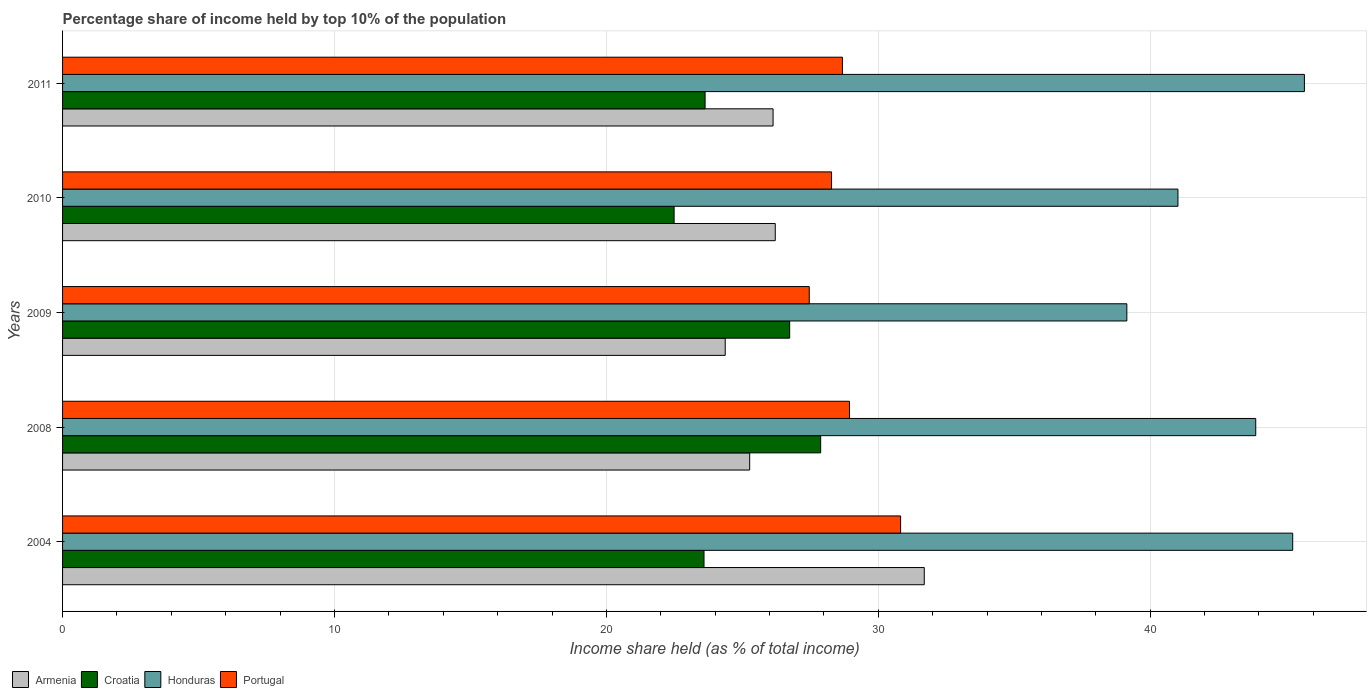Are the number of bars per tick equal to the number of legend labels?
Offer a terse response. Yes. How many bars are there on the 3rd tick from the bottom?
Offer a terse response. 4. What is the label of the 4th group of bars from the top?
Offer a terse response. 2008. What is the percentage share of income held by top 10% of the population in Honduras in 2008?
Keep it short and to the point. 43.88. Across all years, what is the maximum percentage share of income held by top 10% of the population in Armenia?
Your response must be concise. 31.69. Across all years, what is the minimum percentage share of income held by top 10% of the population in Croatia?
Provide a short and direct response. 22.49. In which year was the percentage share of income held by top 10% of the population in Honduras minimum?
Offer a terse response. 2009. What is the total percentage share of income held by top 10% of the population in Honduras in the graph?
Your response must be concise. 214.95. What is the difference between the percentage share of income held by top 10% of the population in Armenia in 2008 and that in 2010?
Your answer should be very brief. -0.94. What is the difference between the percentage share of income held by top 10% of the population in Honduras in 2011 and the percentage share of income held by top 10% of the population in Armenia in 2008?
Offer a terse response. 20.4. What is the average percentage share of income held by top 10% of the population in Portugal per year?
Provide a short and direct response. 28.84. In the year 2009, what is the difference between the percentage share of income held by top 10% of the population in Honduras and percentage share of income held by top 10% of the population in Croatia?
Your answer should be very brief. 12.4. In how many years, is the percentage share of income held by top 10% of the population in Honduras greater than 18 %?
Provide a succinct answer. 5. What is the ratio of the percentage share of income held by top 10% of the population in Armenia in 2008 to that in 2011?
Your response must be concise. 0.97. Is the difference between the percentage share of income held by top 10% of the population in Honduras in 2004 and 2008 greater than the difference between the percentage share of income held by top 10% of the population in Croatia in 2004 and 2008?
Your answer should be very brief. Yes. What is the difference between the highest and the second highest percentage share of income held by top 10% of the population in Portugal?
Your answer should be compact. 1.88. What is the difference between the highest and the lowest percentage share of income held by top 10% of the population in Honduras?
Offer a terse response. 6.53. Is it the case that in every year, the sum of the percentage share of income held by top 10% of the population in Croatia and percentage share of income held by top 10% of the population in Honduras is greater than the sum of percentage share of income held by top 10% of the population in Portugal and percentage share of income held by top 10% of the population in Armenia?
Ensure brevity in your answer.  Yes. What does the 4th bar from the top in 2009 represents?
Your answer should be compact. Armenia. What does the 1st bar from the bottom in 2011 represents?
Your answer should be very brief. Armenia. Is it the case that in every year, the sum of the percentage share of income held by top 10% of the population in Portugal and percentage share of income held by top 10% of the population in Honduras is greater than the percentage share of income held by top 10% of the population in Croatia?
Make the answer very short. Yes. How many bars are there?
Provide a short and direct response. 20. Are all the bars in the graph horizontal?
Provide a succinct answer. Yes. How many years are there in the graph?
Your response must be concise. 5. Does the graph contain grids?
Your response must be concise. Yes. How are the legend labels stacked?
Provide a succinct answer. Horizontal. What is the title of the graph?
Give a very brief answer. Percentage share of income held by top 10% of the population. What is the label or title of the X-axis?
Ensure brevity in your answer.  Income share held (as % of total income). What is the Income share held (as % of total income) in Armenia in 2004?
Your answer should be very brief. 31.69. What is the Income share held (as % of total income) in Croatia in 2004?
Give a very brief answer. 23.59. What is the Income share held (as % of total income) of Honduras in 2004?
Your answer should be compact. 45.24. What is the Income share held (as % of total income) of Portugal in 2004?
Offer a terse response. 30.82. What is the Income share held (as % of total income) of Armenia in 2008?
Provide a short and direct response. 25.27. What is the Income share held (as % of total income) of Croatia in 2008?
Offer a terse response. 27.88. What is the Income share held (as % of total income) in Honduras in 2008?
Ensure brevity in your answer.  43.88. What is the Income share held (as % of total income) of Portugal in 2008?
Keep it short and to the point. 28.94. What is the Income share held (as % of total income) in Armenia in 2009?
Provide a succinct answer. 24.37. What is the Income share held (as % of total income) in Croatia in 2009?
Provide a short and direct response. 26.74. What is the Income share held (as % of total income) in Honduras in 2009?
Offer a very short reply. 39.14. What is the Income share held (as % of total income) of Portugal in 2009?
Offer a very short reply. 27.46. What is the Income share held (as % of total income) in Armenia in 2010?
Your response must be concise. 26.21. What is the Income share held (as % of total income) in Croatia in 2010?
Offer a terse response. 22.49. What is the Income share held (as % of total income) in Honduras in 2010?
Give a very brief answer. 41.02. What is the Income share held (as % of total income) of Portugal in 2010?
Offer a very short reply. 28.28. What is the Income share held (as % of total income) in Armenia in 2011?
Keep it short and to the point. 26.13. What is the Income share held (as % of total income) of Croatia in 2011?
Provide a short and direct response. 23.63. What is the Income share held (as % of total income) in Honduras in 2011?
Offer a very short reply. 45.67. What is the Income share held (as % of total income) of Portugal in 2011?
Offer a terse response. 28.68. Across all years, what is the maximum Income share held (as % of total income) in Armenia?
Your answer should be very brief. 31.69. Across all years, what is the maximum Income share held (as % of total income) of Croatia?
Ensure brevity in your answer.  27.88. Across all years, what is the maximum Income share held (as % of total income) in Honduras?
Offer a very short reply. 45.67. Across all years, what is the maximum Income share held (as % of total income) of Portugal?
Provide a short and direct response. 30.82. Across all years, what is the minimum Income share held (as % of total income) of Armenia?
Your answer should be compact. 24.37. Across all years, what is the minimum Income share held (as % of total income) in Croatia?
Provide a succinct answer. 22.49. Across all years, what is the minimum Income share held (as % of total income) of Honduras?
Your response must be concise. 39.14. Across all years, what is the minimum Income share held (as % of total income) in Portugal?
Your answer should be compact. 27.46. What is the total Income share held (as % of total income) in Armenia in the graph?
Your answer should be compact. 133.67. What is the total Income share held (as % of total income) in Croatia in the graph?
Keep it short and to the point. 124.33. What is the total Income share held (as % of total income) in Honduras in the graph?
Your answer should be very brief. 214.95. What is the total Income share held (as % of total income) of Portugal in the graph?
Offer a very short reply. 144.18. What is the difference between the Income share held (as % of total income) of Armenia in 2004 and that in 2008?
Give a very brief answer. 6.42. What is the difference between the Income share held (as % of total income) of Croatia in 2004 and that in 2008?
Ensure brevity in your answer.  -4.29. What is the difference between the Income share held (as % of total income) of Honduras in 2004 and that in 2008?
Your answer should be very brief. 1.36. What is the difference between the Income share held (as % of total income) of Portugal in 2004 and that in 2008?
Provide a succinct answer. 1.88. What is the difference between the Income share held (as % of total income) in Armenia in 2004 and that in 2009?
Your response must be concise. 7.32. What is the difference between the Income share held (as % of total income) of Croatia in 2004 and that in 2009?
Your answer should be compact. -3.15. What is the difference between the Income share held (as % of total income) of Honduras in 2004 and that in 2009?
Provide a short and direct response. 6.1. What is the difference between the Income share held (as % of total income) of Portugal in 2004 and that in 2009?
Provide a short and direct response. 3.36. What is the difference between the Income share held (as % of total income) of Armenia in 2004 and that in 2010?
Keep it short and to the point. 5.48. What is the difference between the Income share held (as % of total income) of Croatia in 2004 and that in 2010?
Make the answer very short. 1.1. What is the difference between the Income share held (as % of total income) in Honduras in 2004 and that in 2010?
Your response must be concise. 4.22. What is the difference between the Income share held (as % of total income) in Portugal in 2004 and that in 2010?
Keep it short and to the point. 2.54. What is the difference between the Income share held (as % of total income) in Armenia in 2004 and that in 2011?
Keep it short and to the point. 5.56. What is the difference between the Income share held (as % of total income) in Croatia in 2004 and that in 2011?
Provide a succinct answer. -0.04. What is the difference between the Income share held (as % of total income) in Honduras in 2004 and that in 2011?
Make the answer very short. -0.43. What is the difference between the Income share held (as % of total income) in Portugal in 2004 and that in 2011?
Offer a terse response. 2.14. What is the difference between the Income share held (as % of total income) of Croatia in 2008 and that in 2009?
Ensure brevity in your answer.  1.14. What is the difference between the Income share held (as % of total income) of Honduras in 2008 and that in 2009?
Offer a terse response. 4.74. What is the difference between the Income share held (as % of total income) of Portugal in 2008 and that in 2009?
Your answer should be compact. 1.48. What is the difference between the Income share held (as % of total income) in Armenia in 2008 and that in 2010?
Your answer should be very brief. -0.94. What is the difference between the Income share held (as % of total income) in Croatia in 2008 and that in 2010?
Offer a terse response. 5.39. What is the difference between the Income share held (as % of total income) of Honduras in 2008 and that in 2010?
Give a very brief answer. 2.86. What is the difference between the Income share held (as % of total income) in Portugal in 2008 and that in 2010?
Ensure brevity in your answer.  0.66. What is the difference between the Income share held (as % of total income) of Armenia in 2008 and that in 2011?
Make the answer very short. -0.86. What is the difference between the Income share held (as % of total income) of Croatia in 2008 and that in 2011?
Provide a short and direct response. 4.25. What is the difference between the Income share held (as % of total income) of Honduras in 2008 and that in 2011?
Your response must be concise. -1.79. What is the difference between the Income share held (as % of total income) in Portugal in 2008 and that in 2011?
Your answer should be compact. 0.26. What is the difference between the Income share held (as % of total income) of Armenia in 2009 and that in 2010?
Offer a very short reply. -1.84. What is the difference between the Income share held (as % of total income) in Croatia in 2009 and that in 2010?
Your answer should be very brief. 4.25. What is the difference between the Income share held (as % of total income) of Honduras in 2009 and that in 2010?
Give a very brief answer. -1.88. What is the difference between the Income share held (as % of total income) of Portugal in 2009 and that in 2010?
Ensure brevity in your answer.  -0.82. What is the difference between the Income share held (as % of total income) in Armenia in 2009 and that in 2011?
Your answer should be very brief. -1.76. What is the difference between the Income share held (as % of total income) of Croatia in 2009 and that in 2011?
Your answer should be very brief. 3.11. What is the difference between the Income share held (as % of total income) in Honduras in 2009 and that in 2011?
Offer a terse response. -6.53. What is the difference between the Income share held (as % of total income) in Portugal in 2009 and that in 2011?
Keep it short and to the point. -1.22. What is the difference between the Income share held (as % of total income) in Armenia in 2010 and that in 2011?
Offer a terse response. 0.08. What is the difference between the Income share held (as % of total income) in Croatia in 2010 and that in 2011?
Give a very brief answer. -1.14. What is the difference between the Income share held (as % of total income) of Honduras in 2010 and that in 2011?
Your response must be concise. -4.65. What is the difference between the Income share held (as % of total income) of Portugal in 2010 and that in 2011?
Ensure brevity in your answer.  -0.4. What is the difference between the Income share held (as % of total income) of Armenia in 2004 and the Income share held (as % of total income) of Croatia in 2008?
Make the answer very short. 3.81. What is the difference between the Income share held (as % of total income) in Armenia in 2004 and the Income share held (as % of total income) in Honduras in 2008?
Offer a terse response. -12.19. What is the difference between the Income share held (as % of total income) in Armenia in 2004 and the Income share held (as % of total income) in Portugal in 2008?
Ensure brevity in your answer.  2.75. What is the difference between the Income share held (as % of total income) of Croatia in 2004 and the Income share held (as % of total income) of Honduras in 2008?
Provide a succinct answer. -20.29. What is the difference between the Income share held (as % of total income) in Croatia in 2004 and the Income share held (as % of total income) in Portugal in 2008?
Keep it short and to the point. -5.35. What is the difference between the Income share held (as % of total income) of Armenia in 2004 and the Income share held (as % of total income) of Croatia in 2009?
Ensure brevity in your answer.  4.95. What is the difference between the Income share held (as % of total income) of Armenia in 2004 and the Income share held (as % of total income) of Honduras in 2009?
Your answer should be very brief. -7.45. What is the difference between the Income share held (as % of total income) in Armenia in 2004 and the Income share held (as % of total income) in Portugal in 2009?
Provide a short and direct response. 4.23. What is the difference between the Income share held (as % of total income) of Croatia in 2004 and the Income share held (as % of total income) of Honduras in 2009?
Offer a very short reply. -15.55. What is the difference between the Income share held (as % of total income) in Croatia in 2004 and the Income share held (as % of total income) in Portugal in 2009?
Offer a very short reply. -3.87. What is the difference between the Income share held (as % of total income) of Honduras in 2004 and the Income share held (as % of total income) of Portugal in 2009?
Your answer should be compact. 17.78. What is the difference between the Income share held (as % of total income) in Armenia in 2004 and the Income share held (as % of total income) in Croatia in 2010?
Offer a terse response. 9.2. What is the difference between the Income share held (as % of total income) in Armenia in 2004 and the Income share held (as % of total income) in Honduras in 2010?
Keep it short and to the point. -9.33. What is the difference between the Income share held (as % of total income) in Armenia in 2004 and the Income share held (as % of total income) in Portugal in 2010?
Provide a succinct answer. 3.41. What is the difference between the Income share held (as % of total income) of Croatia in 2004 and the Income share held (as % of total income) of Honduras in 2010?
Keep it short and to the point. -17.43. What is the difference between the Income share held (as % of total income) of Croatia in 2004 and the Income share held (as % of total income) of Portugal in 2010?
Provide a short and direct response. -4.69. What is the difference between the Income share held (as % of total income) in Honduras in 2004 and the Income share held (as % of total income) in Portugal in 2010?
Provide a succinct answer. 16.96. What is the difference between the Income share held (as % of total income) of Armenia in 2004 and the Income share held (as % of total income) of Croatia in 2011?
Give a very brief answer. 8.06. What is the difference between the Income share held (as % of total income) of Armenia in 2004 and the Income share held (as % of total income) of Honduras in 2011?
Your answer should be compact. -13.98. What is the difference between the Income share held (as % of total income) of Armenia in 2004 and the Income share held (as % of total income) of Portugal in 2011?
Give a very brief answer. 3.01. What is the difference between the Income share held (as % of total income) of Croatia in 2004 and the Income share held (as % of total income) of Honduras in 2011?
Give a very brief answer. -22.08. What is the difference between the Income share held (as % of total income) of Croatia in 2004 and the Income share held (as % of total income) of Portugal in 2011?
Provide a succinct answer. -5.09. What is the difference between the Income share held (as % of total income) of Honduras in 2004 and the Income share held (as % of total income) of Portugal in 2011?
Keep it short and to the point. 16.56. What is the difference between the Income share held (as % of total income) in Armenia in 2008 and the Income share held (as % of total income) in Croatia in 2009?
Make the answer very short. -1.47. What is the difference between the Income share held (as % of total income) of Armenia in 2008 and the Income share held (as % of total income) of Honduras in 2009?
Provide a short and direct response. -13.87. What is the difference between the Income share held (as % of total income) of Armenia in 2008 and the Income share held (as % of total income) of Portugal in 2009?
Ensure brevity in your answer.  -2.19. What is the difference between the Income share held (as % of total income) of Croatia in 2008 and the Income share held (as % of total income) of Honduras in 2009?
Offer a terse response. -11.26. What is the difference between the Income share held (as % of total income) of Croatia in 2008 and the Income share held (as % of total income) of Portugal in 2009?
Your response must be concise. 0.42. What is the difference between the Income share held (as % of total income) in Honduras in 2008 and the Income share held (as % of total income) in Portugal in 2009?
Your answer should be compact. 16.42. What is the difference between the Income share held (as % of total income) of Armenia in 2008 and the Income share held (as % of total income) of Croatia in 2010?
Your answer should be very brief. 2.78. What is the difference between the Income share held (as % of total income) in Armenia in 2008 and the Income share held (as % of total income) in Honduras in 2010?
Your answer should be very brief. -15.75. What is the difference between the Income share held (as % of total income) of Armenia in 2008 and the Income share held (as % of total income) of Portugal in 2010?
Make the answer very short. -3.01. What is the difference between the Income share held (as % of total income) of Croatia in 2008 and the Income share held (as % of total income) of Honduras in 2010?
Provide a succinct answer. -13.14. What is the difference between the Income share held (as % of total income) of Croatia in 2008 and the Income share held (as % of total income) of Portugal in 2010?
Your answer should be compact. -0.4. What is the difference between the Income share held (as % of total income) in Honduras in 2008 and the Income share held (as % of total income) in Portugal in 2010?
Provide a succinct answer. 15.6. What is the difference between the Income share held (as % of total income) in Armenia in 2008 and the Income share held (as % of total income) in Croatia in 2011?
Offer a very short reply. 1.64. What is the difference between the Income share held (as % of total income) of Armenia in 2008 and the Income share held (as % of total income) of Honduras in 2011?
Your response must be concise. -20.4. What is the difference between the Income share held (as % of total income) of Armenia in 2008 and the Income share held (as % of total income) of Portugal in 2011?
Ensure brevity in your answer.  -3.41. What is the difference between the Income share held (as % of total income) of Croatia in 2008 and the Income share held (as % of total income) of Honduras in 2011?
Keep it short and to the point. -17.79. What is the difference between the Income share held (as % of total income) of Croatia in 2008 and the Income share held (as % of total income) of Portugal in 2011?
Your answer should be compact. -0.8. What is the difference between the Income share held (as % of total income) in Armenia in 2009 and the Income share held (as % of total income) in Croatia in 2010?
Give a very brief answer. 1.88. What is the difference between the Income share held (as % of total income) of Armenia in 2009 and the Income share held (as % of total income) of Honduras in 2010?
Give a very brief answer. -16.65. What is the difference between the Income share held (as % of total income) in Armenia in 2009 and the Income share held (as % of total income) in Portugal in 2010?
Make the answer very short. -3.91. What is the difference between the Income share held (as % of total income) in Croatia in 2009 and the Income share held (as % of total income) in Honduras in 2010?
Your response must be concise. -14.28. What is the difference between the Income share held (as % of total income) in Croatia in 2009 and the Income share held (as % of total income) in Portugal in 2010?
Offer a very short reply. -1.54. What is the difference between the Income share held (as % of total income) in Honduras in 2009 and the Income share held (as % of total income) in Portugal in 2010?
Provide a succinct answer. 10.86. What is the difference between the Income share held (as % of total income) in Armenia in 2009 and the Income share held (as % of total income) in Croatia in 2011?
Your answer should be very brief. 0.74. What is the difference between the Income share held (as % of total income) of Armenia in 2009 and the Income share held (as % of total income) of Honduras in 2011?
Make the answer very short. -21.3. What is the difference between the Income share held (as % of total income) of Armenia in 2009 and the Income share held (as % of total income) of Portugal in 2011?
Your response must be concise. -4.31. What is the difference between the Income share held (as % of total income) in Croatia in 2009 and the Income share held (as % of total income) in Honduras in 2011?
Your answer should be very brief. -18.93. What is the difference between the Income share held (as % of total income) in Croatia in 2009 and the Income share held (as % of total income) in Portugal in 2011?
Keep it short and to the point. -1.94. What is the difference between the Income share held (as % of total income) of Honduras in 2009 and the Income share held (as % of total income) of Portugal in 2011?
Offer a terse response. 10.46. What is the difference between the Income share held (as % of total income) in Armenia in 2010 and the Income share held (as % of total income) in Croatia in 2011?
Give a very brief answer. 2.58. What is the difference between the Income share held (as % of total income) of Armenia in 2010 and the Income share held (as % of total income) of Honduras in 2011?
Your response must be concise. -19.46. What is the difference between the Income share held (as % of total income) of Armenia in 2010 and the Income share held (as % of total income) of Portugal in 2011?
Your response must be concise. -2.47. What is the difference between the Income share held (as % of total income) in Croatia in 2010 and the Income share held (as % of total income) in Honduras in 2011?
Your answer should be very brief. -23.18. What is the difference between the Income share held (as % of total income) in Croatia in 2010 and the Income share held (as % of total income) in Portugal in 2011?
Provide a succinct answer. -6.19. What is the difference between the Income share held (as % of total income) of Honduras in 2010 and the Income share held (as % of total income) of Portugal in 2011?
Provide a succinct answer. 12.34. What is the average Income share held (as % of total income) in Armenia per year?
Keep it short and to the point. 26.73. What is the average Income share held (as % of total income) of Croatia per year?
Your answer should be compact. 24.87. What is the average Income share held (as % of total income) in Honduras per year?
Provide a short and direct response. 42.99. What is the average Income share held (as % of total income) of Portugal per year?
Keep it short and to the point. 28.84. In the year 2004, what is the difference between the Income share held (as % of total income) in Armenia and Income share held (as % of total income) in Croatia?
Your answer should be very brief. 8.1. In the year 2004, what is the difference between the Income share held (as % of total income) of Armenia and Income share held (as % of total income) of Honduras?
Provide a succinct answer. -13.55. In the year 2004, what is the difference between the Income share held (as % of total income) of Armenia and Income share held (as % of total income) of Portugal?
Your answer should be compact. 0.87. In the year 2004, what is the difference between the Income share held (as % of total income) in Croatia and Income share held (as % of total income) in Honduras?
Ensure brevity in your answer.  -21.65. In the year 2004, what is the difference between the Income share held (as % of total income) in Croatia and Income share held (as % of total income) in Portugal?
Keep it short and to the point. -7.23. In the year 2004, what is the difference between the Income share held (as % of total income) in Honduras and Income share held (as % of total income) in Portugal?
Your answer should be compact. 14.42. In the year 2008, what is the difference between the Income share held (as % of total income) in Armenia and Income share held (as % of total income) in Croatia?
Keep it short and to the point. -2.61. In the year 2008, what is the difference between the Income share held (as % of total income) of Armenia and Income share held (as % of total income) of Honduras?
Offer a very short reply. -18.61. In the year 2008, what is the difference between the Income share held (as % of total income) in Armenia and Income share held (as % of total income) in Portugal?
Your response must be concise. -3.67. In the year 2008, what is the difference between the Income share held (as % of total income) of Croatia and Income share held (as % of total income) of Portugal?
Offer a terse response. -1.06. In the year 2008, what is the difference between the Income share held (as % of total income) in Honduras and Income share held (as % of total income) in Portugal?
Ensure brevity in your answer.  14.94. In the year 2009, what is the difference between the Income share held (as % of total income) of Armenia and Income share held (as % of total income) of Croatia?
Provide a short and direct response. -2.37. In the year 2009, what is the difference between the Income share held (as % of total income) in Armenia and Income share held (as % of total income) in Honduras?
Provide a short and direct response. -14.77. In the year 2009, what is the difference between the Income share held (as % of total income) in Armenia and Income share held (as % of total income) in Portugal?
Your answer should be compact. -3.09. In the year 2009, what is the difference between the Income share held (as % of total income) in Croatia and Income share held (as % of total income) in Portugal?
Ensure brevity in your answer.  -0.72. In the year 2009, what is the difference between the Income share held (as % of total income) in Honduras and Income share held (as % of total income) in Portugal?
Keep it short and to the point. 11.68. In the year 2010, what is the difference between the Income share held (as % of total income) in Armenia and Income share held (as % of total income) in Croatia?
Your response must be concise. 3.72. In the year 2010, what is the difference between the Income share held (as % of total income) of Armenia and Income share held (as % of total income) of Honduras?
Your answer should be very brief. -14.81. In the year 2010, what is the difference between the Income share held (as % of total income) in Armenia and Income share held (as % of total income) in Portugal?
Offer a very short reply. -2.07. In the year 2010, what is the difference between the Income share held (as % of total income) in Croatia and Income share held (as % of total income) in Honduras?
Your response must be concise. -18.53. In the year 2010, what is the difference between the Income share held (as % of total income) in Croatia and Income share held (as % of total income) in Portugal?
Make the answer very short. -5.79. In the year 2010, what is the difference between the Income share held (as % of total income) in Honduras and Income share held (as % of total income) in Portugal?
Your response must be concise. 12.74. In the year 2011, what is the difference between the Income share held (as % of total income) of Armenia and Income share held (as % of total income) of Honduras?
Give a very brief answer. -19.54. In the year 2011, what is the difference between the Income share held (as % of total income) in Armenia and Income share held (as % of total income) in Portugal?
Make the answer very short. -2.55. In the year 2011, what is the difference between the Income share held (as % of total income) of Croatia and Income share held (as % of total income) of Honduras?
Provide a succinct answer. -22.04. In the year 2011, what is the difference between the Income share held (as % of total income) of Croatia and Income share held (as % of total income) of Portugal?
Give a very brief answer. -5.05. In the year 2011, what is the difference between the Income share held (as % of total income) in Honduras and Income share held (as % of total income) in Portugal?
Offer a very short reply. 16.99. What is the ratio of the Income share held (as % of total income) in Armenia in 2004 to that in 2008?
Offer a terse response. 1.25. What is the ratio of the Income share held (as % of total income) in Croatia in 2004 to that in 2008?
Give a very brief answer. 0.85. What is the ratio of the Income share held (as % of total income) of Honduras in 2004 to that in 2008?
Offer a very short reply. 1.03. What is the ratio of the Income share held (as % of total income) of Portugal in 2004 to that in 2008?
Ensure brevity in your answer.  1.06. What is the ratio of the Income share held (as % of total income) of Armenia in 2004 to that in 2009?
Keep it short and to the point. 1.3. What is the ratio of the Income share held (as % of total income) in Croatia in 2004 to that in 2009?
Provide a succinct answer. 0.88. What is the ratio of the Income share held (as % of total income) of Honduras in 2004 to that in 2009?
Provide a short and direct response. 1.16. What is the ratio of the Income share held (as % of total income) in Portugal in 2004 to that in 2009?
Give a very brief answer. 1.12. What is the ratio of the Income share held (as % of total income) in Armenia in 2004 to that in 2010?
Ensure brevity in your answer.  1.21. What is the ratio of the Income share held (as % of total income) of Croatia in 2004 to that in 2010?
Give a very brief answer. 1.05. What is the ratio of the Income share held (as % of total income) in Honduras in 2004 to that in 2010?
Provide a short and direct response. 1.1. What is the ratio of the Income share held (as % of total income) in Portugal in 2004 to that in 2010?
Your answer should be very brief. 1.09. What is the ratio of the Income share held (as % of total income) in Armenia in 2004 to that in 2011?
Make the answer very short. 1.21. What is the ratio of the Income share held (as % of total income) in Honduras in 2004 to that in 2011?
Your response must be concise. 0.99. What is the ratio of the Income share held (as % of total income) in Portugal in 2004 to that in 2011?
Keep it short and to the point. 1.07. What is the ratio of the Income share held (as % of total income) of Armenia in 2008 to that in 2009?
Give a very brief answer. 1.04. What is the ratio of the Income share held (as % of total income) in Croatia in 2008 to that in 2009?
Offer a terse response. 1.04. What is the ratio of the Income share held (as % of total income) of Honduras in 2008 to that in 2009?
Provide a succinct answer. 1.12. What is the ratio of the Income share held (as % of total income) of Portugal in 2008 to that in 2009?
Provide a succinct answer. 1.05. What is the ratio of the Income share held (as % of total income) in Armenia in 2008 to that in 2010?
Give a very brief answer. 0.96. What is the ratio of the Income share held (as % of total income) in Croatia in 2008 to that in 2010?
Provide a succinct answer. 1.24. What is the ratio of the Income share held (as % of total income) in Honduras in 2008 to that in 2010?
Ensure brevity in your answer.  1.07. What is the ratio of the Income share held (as % of total income) in Portugal in 2008 to that in 2010?
Ensure brevity in your answer.  1.02. What is the ratio of the Income share held (as % of total income) in Armenia in 2008 to that in 2011?
Offer a terse response. 0.97. What is the ratio of the Income share held (as % of total income) of Croatia in 2008 to that in 2011?
Your response must be concise. 1.18. What is the ratio of the Income share held (as % of total income) in Honduras in 2008 to that in 2011?
Your answer should be very brief. 0.96. What is the ratio of the Income share held (as % of total income) in Portugal in 2008 to that in 2011?
Keep it short and to the point. 1.01. What is the ratio of the Income share held (as % of total income) in Armenia in 2009 to that in 2010?
Give a very brief answer. 0.93. What is the ratio of the Income share held (as % of total income) of Croatia in 2009 to that in 2010?
Offer a terse response. 1.19. What is the ratio of the Income share held (as % of total income) in Honduras in 2009 to that in 2010?
Give a very brief answer. 0.95. What is the ratio of the Income share held (as % of total income) in Portugal in 2009 to that in 2010?
Ensure brevity in your answer.  0.97. What is the ratio of the Income share held (as % of total income) of Armenia in 2009 to that in 2011?
Give a very brief answer. 0.93. What is the ratio of the Income share held (as % of total income) in Croatia in 2009 to that in 2011?
Offer a terse response. 1.13. What is the ratio of the Income share held (as % of total income) of Honduras in 2009 to that in 2011?
Ensure brevity in your answer.  0.86. What is the ratio of the Income share held (as % of total income) of Portugal in 2009 to that in 2011?
Keep it short and to the point. 0.96. What is the ratio of the Income share held (as % of total income) in Croatia in 2010 to that in 2011?
Your answer should be very brief. 0.95. What is the ratio of the Income share held (as % of total income) of Honduras in 2010 to that in 2011?
Provide a succinct answer. 0.9. What is the ratio of the Income share held (as % of total income) in Portugal in 2010 to that in 2011?
Keep it short and to the point. 0.99. What is the difference between the highest and the second highest Income share held (as % of total income) of Armenia?
Offer a very short reply. 5.48. What is the difference between the highest and the second highest Income share held (as % of total income) of Croatia?
Your answer should be compact. 1.14. What is the difference between the highest and the second highest Income share held (as % of total income) in Honduras?
Your response must be concise. 0.43. What is the difference between the highest and the second highest Income share held (as % of total income) of Portugal?
Offer a very short reply. 1.88. What is the difference between the highest and the lowest Income share held (as % of total income) of Armenia?
Provide a succinct answer. 7.32. What is the difference between the highest and the lowest Income share held (as % of total income) in Croatia?
Your response must be concise. 5.39. What is the difference between the highest and the lowest Income share held (as % of total income) of Honduras?
Provide a succinct answer. 6.53. What is the difference between the highest and the lowest Income share held (as % of total income) in Portugal?
Keep it short and to the point. 3.36. 